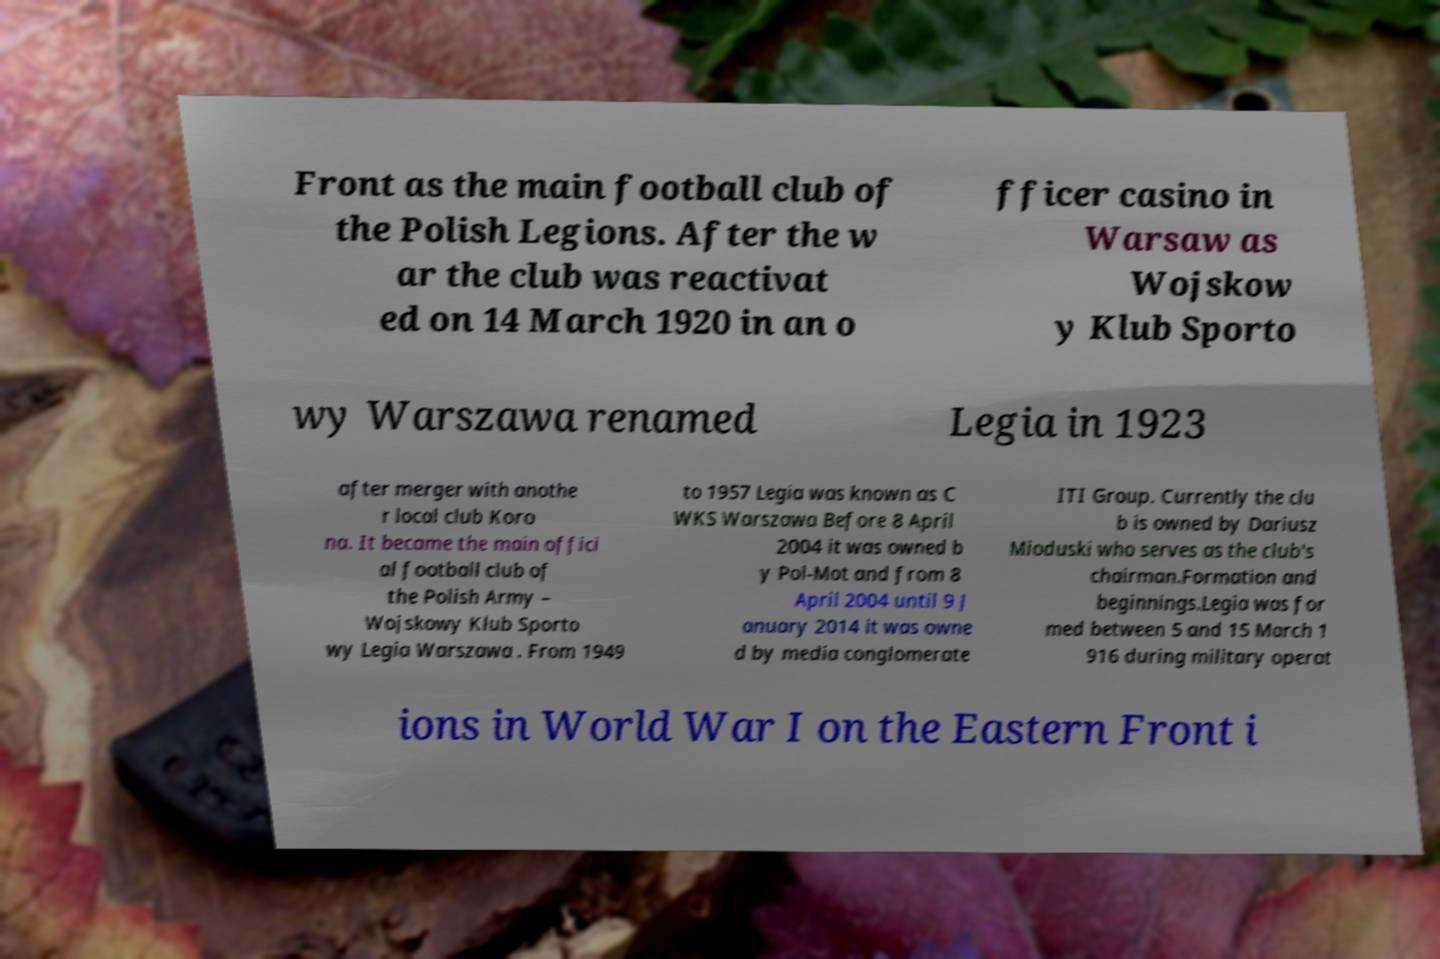Can you accurately transcribe the text from the provided image for me? Front as the main football club of the Polish Legions. After the w ar the club was reactivat ed on 14 March 1920 in an o fficer casino in Warsaw as Wojskow y Klub Sporto wy Warszawa renamed Legia in 1923 after merger with anothe r local club Koro na. It became the main offici al football club of the Polish Army – Wojskowy Klub Sporto wy Legia Warszawa . From 1949 to 1957 Legia was known as C WKS Warszawa Before 8 April 2004 it was owned b y Pol-Mot and from 8 April 2004 until 9 J anuary 2014 it was owne d by media conglomerate ITI Group. Currently the clu b is owned by Dariusz Mioduski who serves as the club's chairman.Formation and beginnings.Legia was for med between 5 and 15 March 1 916 during military operat ions in World War I on the Eastern Front i 